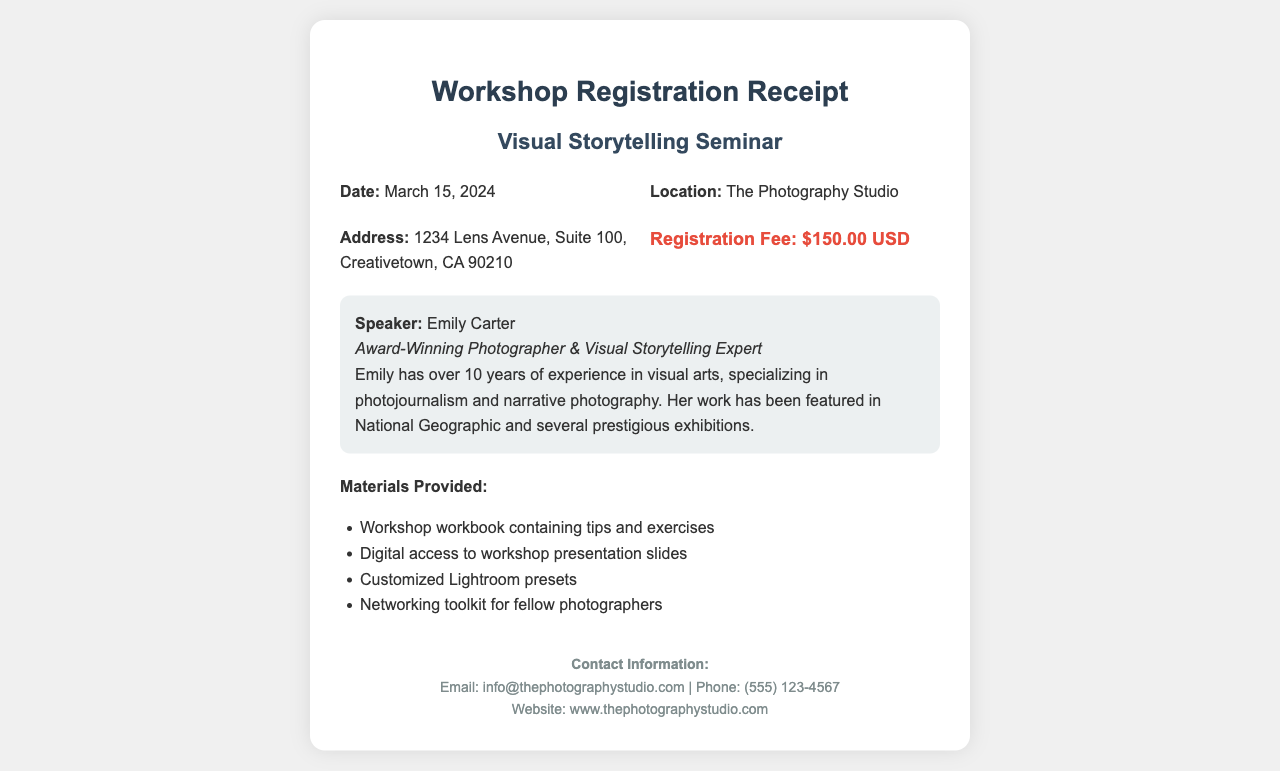What is the date of the seminar? The document states that the seminar will take place on March 15, 2024.
Answer: March 15, 2024 What is the registration fee? The registration fee mentioned in the document is $150.00 USD.
Answer: $150.00 USD Who is the speaker? The document identifies the speaker as Emily Carter.
Answer: Emily Carter What materials are provided? The document lists various materials that will be provided to participants, including a workshop workbook.
Answer: Workshop workbook containing tips and exercises Where is the seminar located? The document specifies that the seminar will be held at The Photography Studio.
Answer: The Photography Studio What is the address for the seminar location? The document gives a complete address for the seminar at 1234 Lens Avenue, Suite 100, Creativetown, CA 90210.
Answer: 1234 Lens Avenue, Suite 100, Creativetown, CA 90210 How many years of experience does the speaker have? The document mentions that Emily Carter has over 10 years of experience in visual arts.
Answer: 10 years What type of photography does the speaker specialize in? The document indicates that the speaker specializes in photojournalism and narrative photography.
Answer: Photojournalism and narrative photography What is the contact email for the photography studio? The document provides a contact email, which is info@thephotographystudio.com.
Answer: info@thephotographystudio.com 